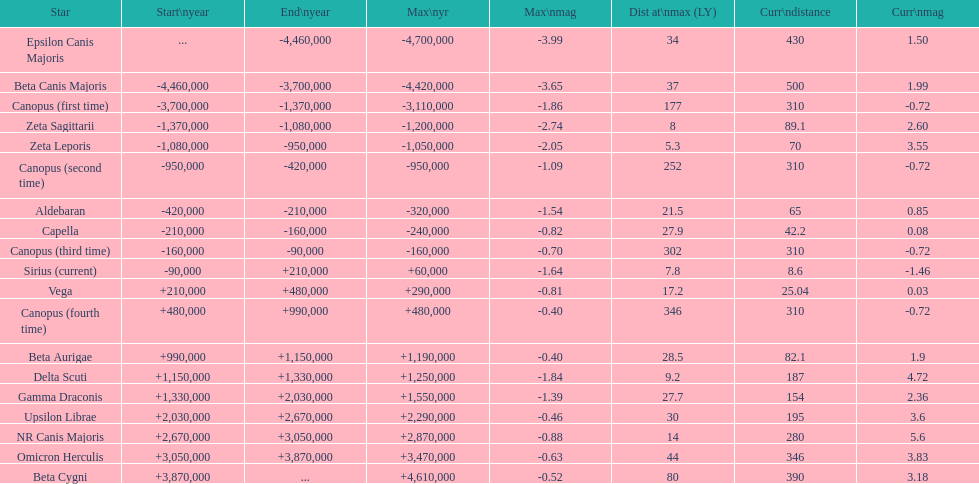What is the difference in the nearest current distance and farthest current distance? 491.4. 